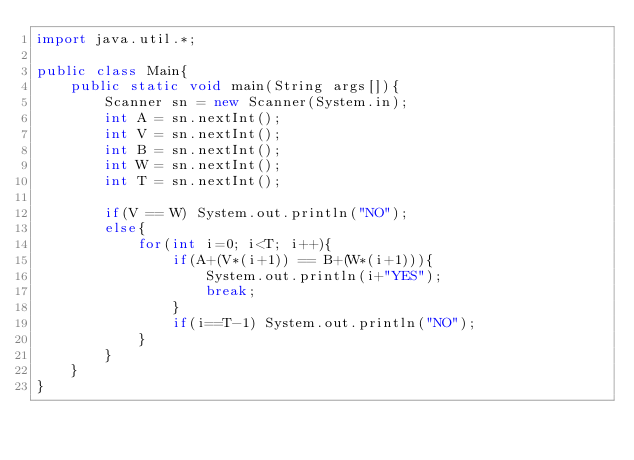<code> <loc_0><loc_0><loc_500><loc_500><_Java_>import java.util.*;

public class Main{
    public static void main(String args[]){
        Scanner sn = new Scanner(System.in);
        int A = sn.nextInt();
        int V = sn.nextInt();
        int B = sn.nextInt();
        int W = sn.nextInt();
        int T = sn.nextInt();

        if(V == W) System.out.println("NO");
        else{
            for(int i=0; i<T; i++){
                if(A+(V*(i+1)) == B+(W*(i+1))){
                    System.out.println(i+"YES");
                    break;
                }
                if(i==T-1) System.out.println("NO");
            }
        }
    }
}</code> 